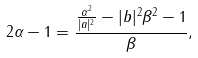<formula> <loc_0><loc_0><loc_500><loc_500>2 \alpha - 1 = \frac { \frac { \alpha ^ { 2 } } { | a | ^ { 2 } } - | b | ^ { 2 } \beta ^ { 2 } - 1 } { \beta } ,</formula> 